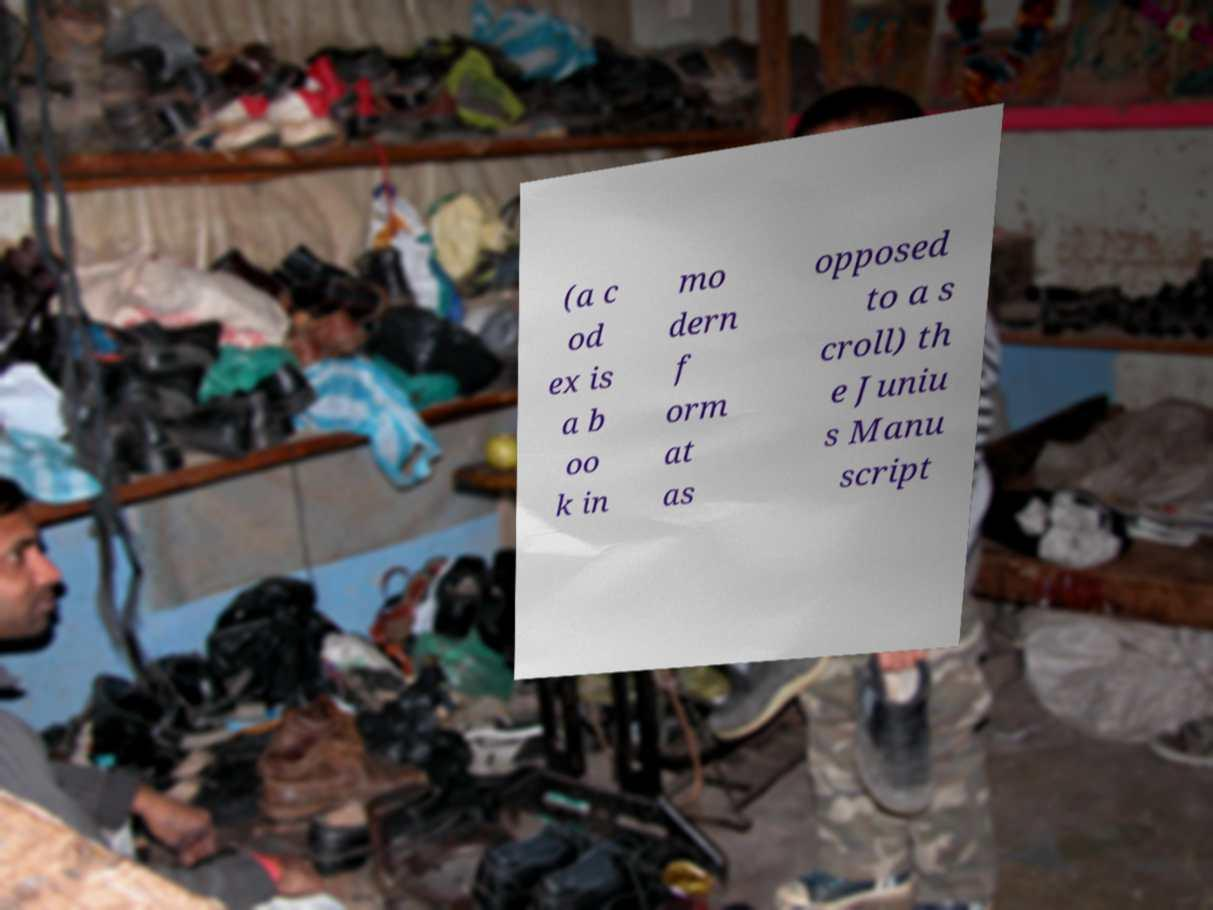What messages or text are displayed in this image? I need them in a readable, typed format. (a c od ex is a b oo k in mo dern f orm at as opposed to a s croll) th e Juniu s Manu script 